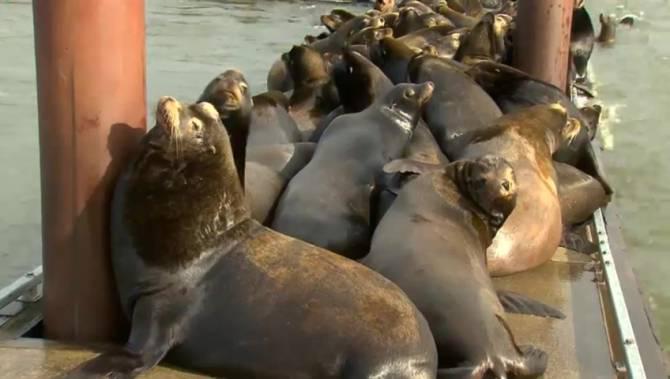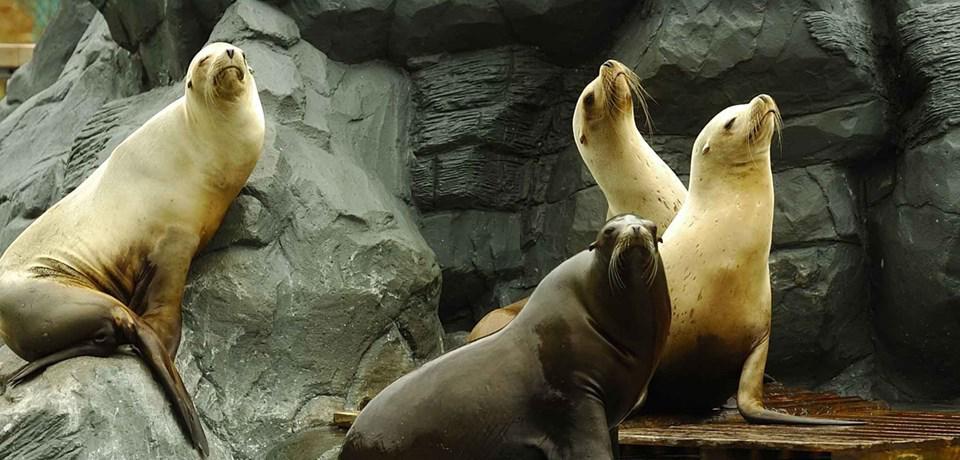The first image is the image on the left, the second image is the image on the right. Analyze the images presented: Is the assertion "In at least one of the images, there are visible holes in the edges of the floating dock." valid? Answer yes or no. No. The first image is the image on the left, the second image is the image on the right. Evaluate the accuracy of this statement regarding the images: "Each image shows a mass of seals on a platform with brown vertical columns.". Is it true? Answer yes or no. No. 